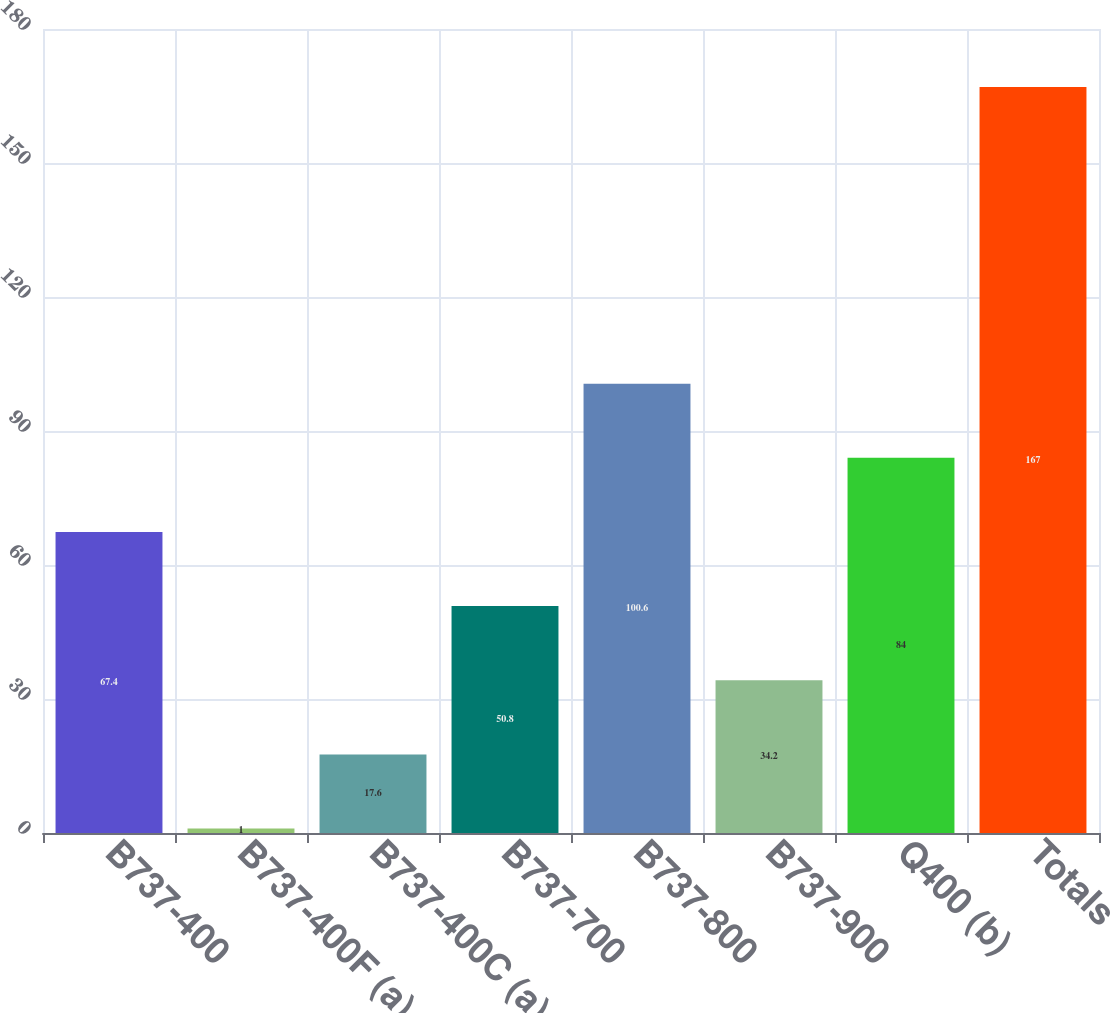Convert chart. <chart><loc_0><loc_0><loc_500><loc_500><bar_chart><fcel>B737-400<fcel>B737-400F (a)<fcel>B737-400C (a)<fcel>B737-700<fcel>B737-800<fcel>B737-900<fcel>Q400 (b)<fcel>Totals<nl><fcel>67.4<fcel>1<fcel>17.6<fcel>50.8<fcel>100.6<fcel>34.2<fcel>84<fcel>167<nl></chart> 